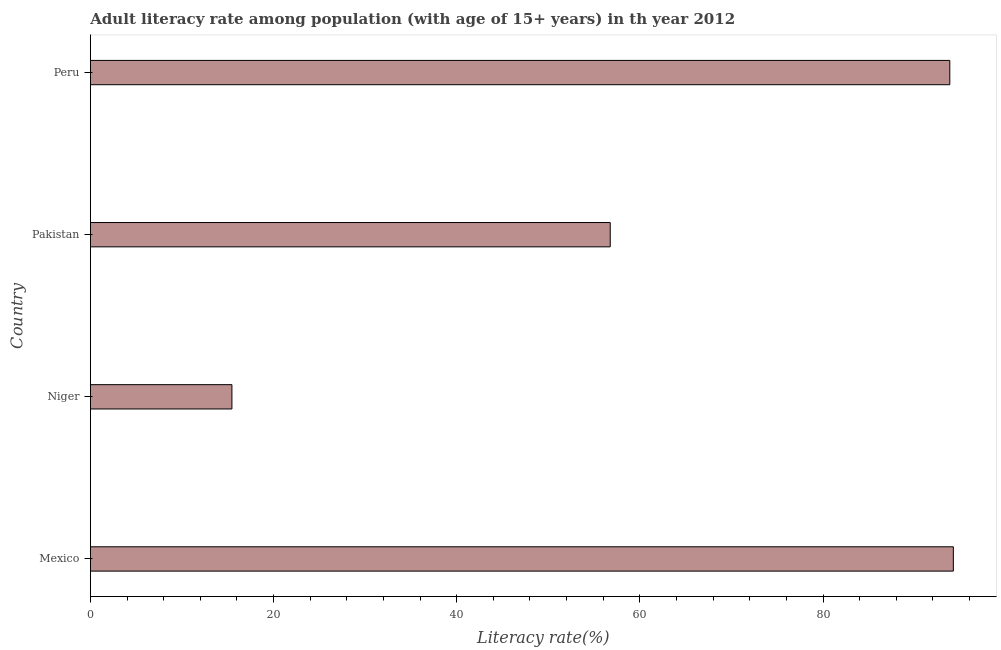Does the graph contain any zero values?
Provide a short and direct response. No. What is the title of the graph?
Provide a short and direct response. Adult literacy rate among population (with age of 15+ years) in th year 2012. What is the label or title of the X-axis?
Ensure brevity in your answer.  Literacy rate(%). What is the adult literacy rate in Pakistan?
Your answer should be compact. 56.76. Across all countries, what is the maximum adult literacy rate?
Your answer should be very brief. 94.23. Across all countries, what is the minimum adult literacy rate?
Make the answer very short. 15.46. In which country was the adult literacy rate maximum?
Your answer should be compact. Mexico. In which country was the adult literacy rate minimum?
Provide a succinct answer. Niger. What is the sum of the adult literacy rate?
Your answer should be compact. 260.29. What is the difference between the adult literacy rate in Niger and Peru?
Offer a terse response. -78.39. What is the average adult literacy rate per country?
Ensure brevity in your answer.  65.07. What is the median adult literacy rate?
Provide a short and direct response. 75.3. What is the ratio of the adult literacy rate in Pakistan to that in Peru?
Offer a terse response. 0.6. Is the adult literacy rate in Niger less than that in Pakistan?
Your answer should be very brief. Yes. Is the difference between the adult literacy rate in Niger and Peru greater than the difference between any two countries?
Give a very brief answer. No. What is the difference between the highest and the second highest adult literacy rate?
Give a very brief answer. 0.39. What is the difference between the highest and the lowest adult literacy rate?
Your answer should be compact. 78.77. In how many countries, is the adult literacy rate greater than the average adult literacy rate taken over all countries?
Keep it short and to the point. 2. How many bars are there?
Ensure brevity in your answer.  4. How many countries are there in the graph?
Offer a terse response. 4. What is the Literacy rate(%) in Mexico?
Offer a very short reply. 94.23. What is the Literacy rate(%) of Niger?
Your response must be concise. 15.46. What is the Literacy rate(%) of Pakistan?
Give a very brief answer. 56.76. What is the Literacy rate(%) in Peru?
Provide a succinct answer. 93.84. What is the difference between the Literacy rate(%) in Mexico and Niger?
Your answer should be very brief. 78.77. What is the difference between the Literacy rate(%) in Mexico and Pakistan?
Give a very brief answer. 37.46. What is the difference between the Literacy rate(%) in Mexico and Peru?
Your answer should be compact. 0.39. What is the difference between the Literacy rate(%) in Niger and Pakistan?
Offer a very short reply. -41.31. What is the difference between the Literacy rate(%) in Niger and Peru?
Offer a terse response. -78.39. What is the difference between the Literacy rate(%) in Pakistan and Peru?
Your response must be concise. -37.08. What is the ratio of the Literacy rate(%) in Mexico to that in Niger?
Offer a very short reply. 6.1. What is the ratio of the Literacy rate(%) in Mexico to that in Pakistan?
Ensure brevity in your answer.  1.66. What is the ratio of the Literacy rate(%) in Mexico to that in Peru?
Provide a short and direct response. 1. What is the ratio of the Literacy rate(%) in Niger to that in Pakistan?
Provide a short and direct response. 0.27. What is the ratio of the Literacy rate(%) in Niger to that in Peru?
Your answer should be very brief. 0.17. What is the ratio of the Literacy rate(%) in Pakistan to that in Peru?
Your answer should be very brief. 0.6. 